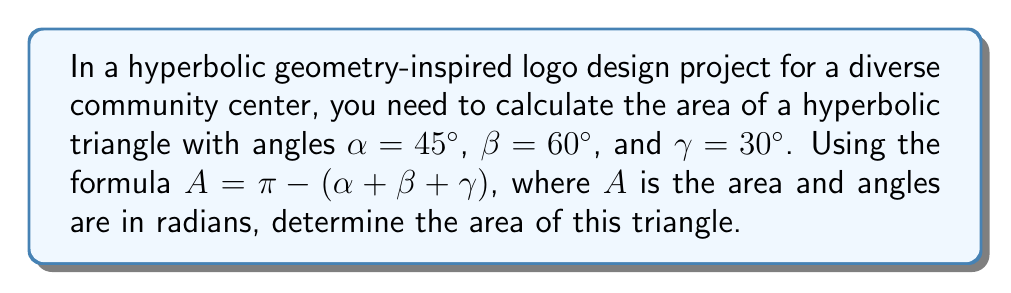Help me with this question. To solve this problem, we'll follow these steps:

1. Convert the given angles from degrees to radians:
   $\alpha = 45° = \frac{\pi}{4}$ radians
   $\beta = 60° = \frac{\pi}{3}$ radians
   $\gamma = 30° = \frac{\pi}{6}$ radians

2. Apply the formula for the area of a hyperbolic triangle:
   $A = \pi - (\alpha + \beta + \gamma)$

3. Substitute the values:
   $A = \pi - (\frac{\pi}{4} + \frac{\pi}{3} + \frac{\pi}{6})$

4. Simplify the expression:
   $A = \pi - (\frac{3\pi}{12} + \frac{4\pi}{12} + \frac{2\pi}{12})$
   $A = \pi - \frac{9\pi}{12}$

5. Perform the subtraction:
   $A = \frac{12\pi}{12} - \frac{9\pi}{12} = \frac{3\pi}{12} = \frac{\pi}{4}$

Therefore, the area of the hyperbolic triangle is $\frac{\pi}{4}$ square units.
Answer: $\frac{\pi}{4}$ square units 